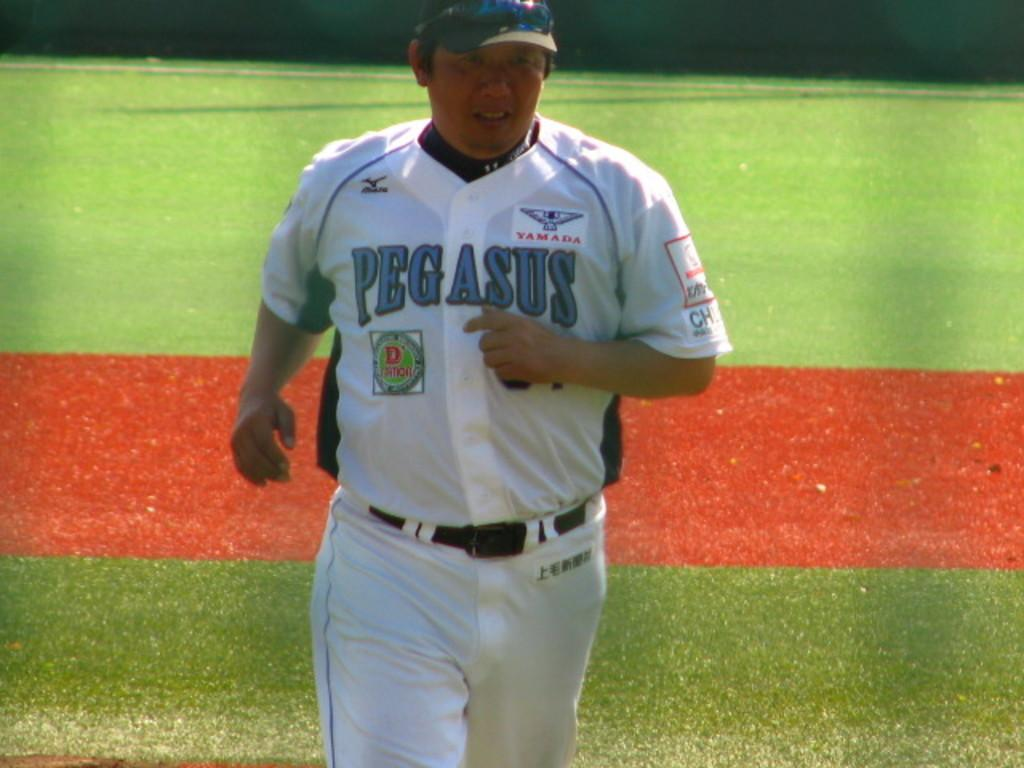<image>
Provide a brief description of the given image. The baseball player on the pitch has a pegasus top on. 